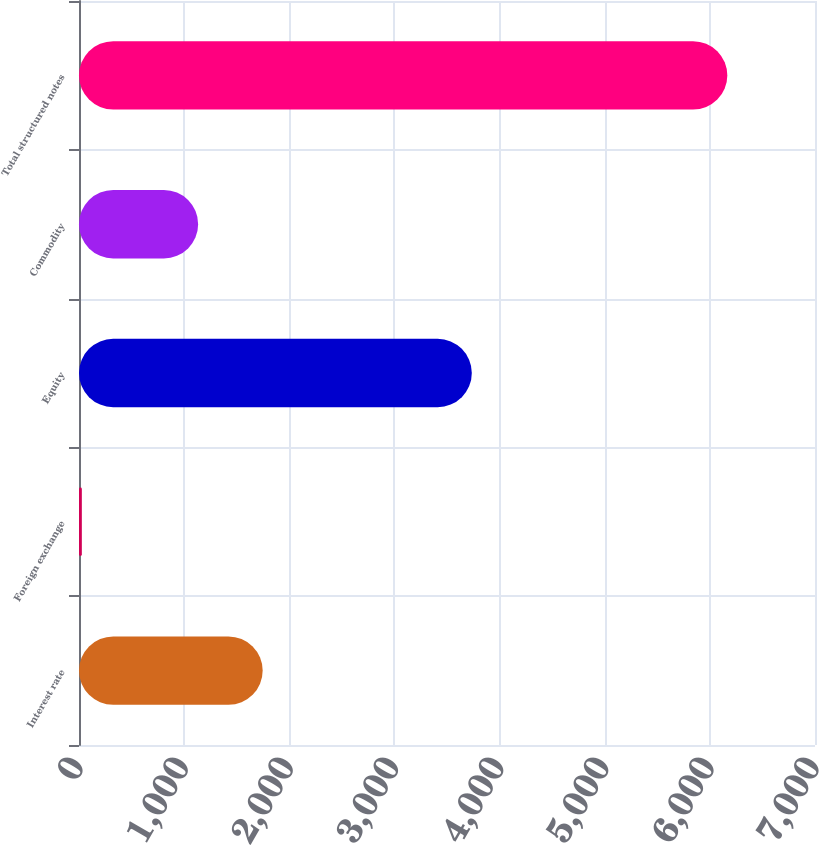Convert chart to OTSL. <chart><loc_0><loc_0><loc_500><loc_500><bar_chart><fcel>Interest rate<fcel>Foreign exchange<fcel>Equity<fcel>Commodity<fcel>Total structured notes<nl><fcel>1746.9<fcel>27<fcel>3736<fcel>1133<fcel>6166<nl></chart> 